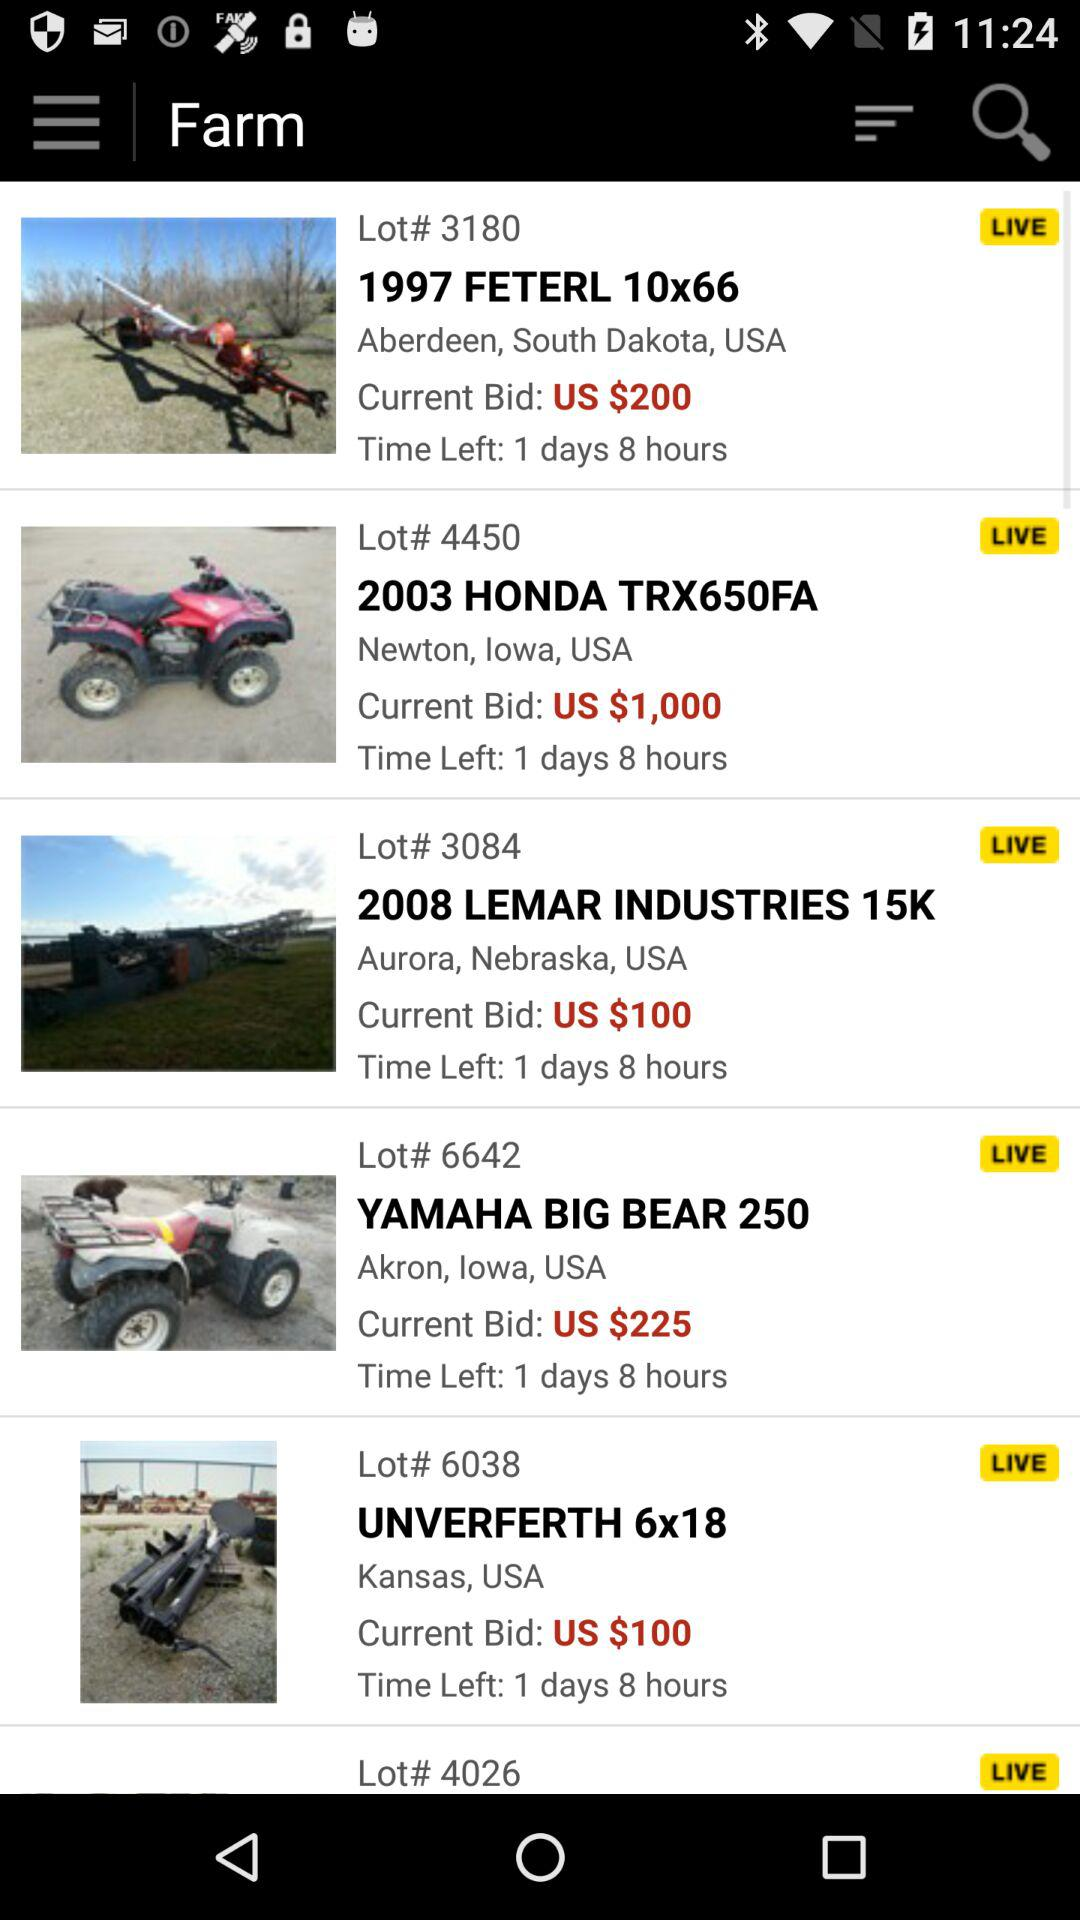What is the current bid for "YAMAHA BIG BEAR 250"? The current bid for "YAMAHA BIG BEAR 250" is $225 USD. 